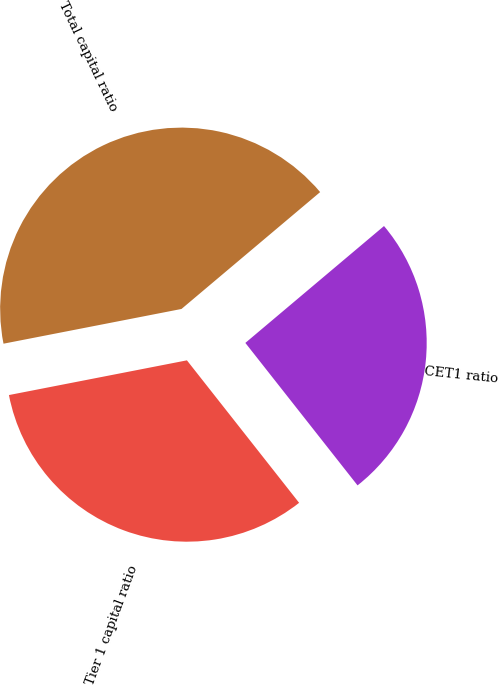Convert chart. <chart><loc_0><loc_0><loc_500><loc_500><pie_chart><fcel>CET1 ratio<fcel>Tier 1 capital ratio<fcel>Total capital ratio<nl><fcel>25.53%<fcel>32.55%<fcel>41.92%<nl></chart> 